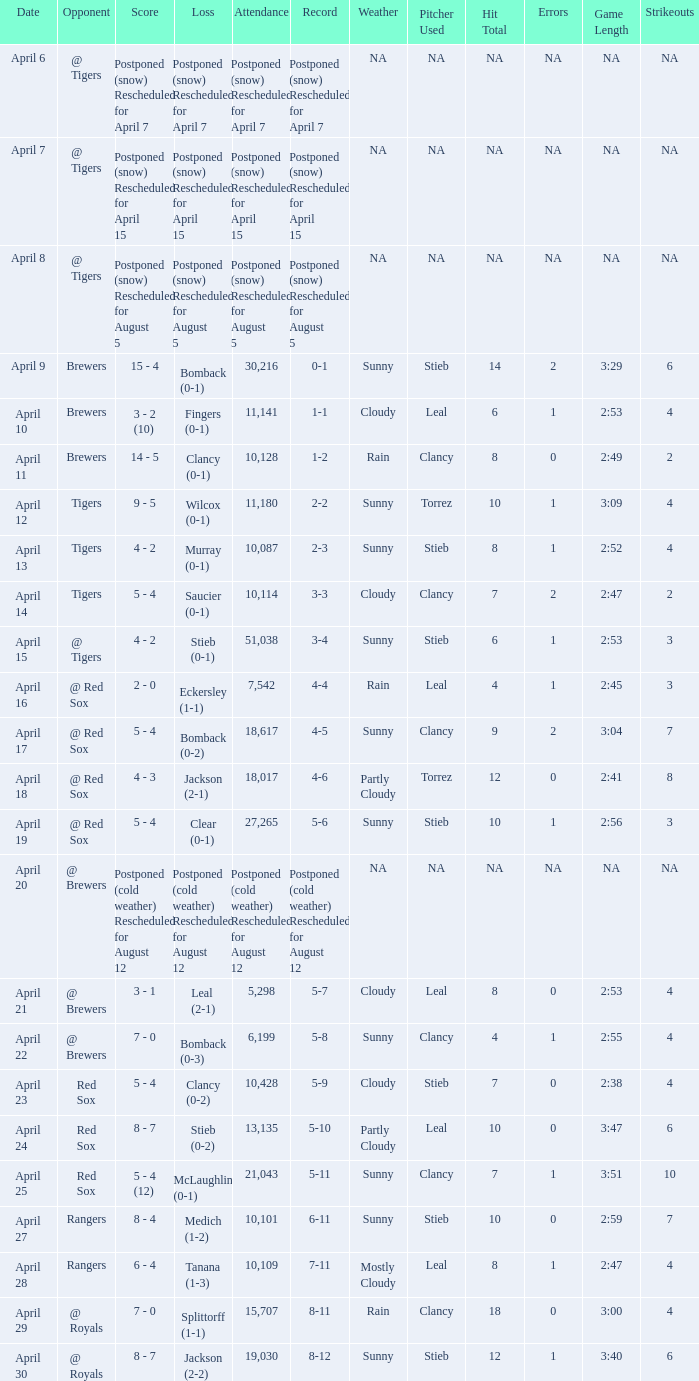Which record is dated April 8? Postponed (snow) Rescheduled for August 5. 